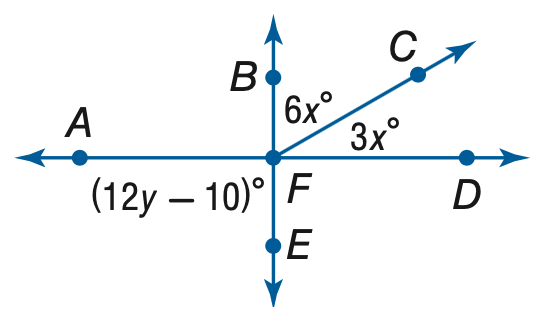Answer the mathemtical geometry problem and directly provide the correct option letter.
Question: Find y so that B E and A D are perpendicular.
Choices: A: 6.7 B: 8.3 C: 10 D: 90 B 